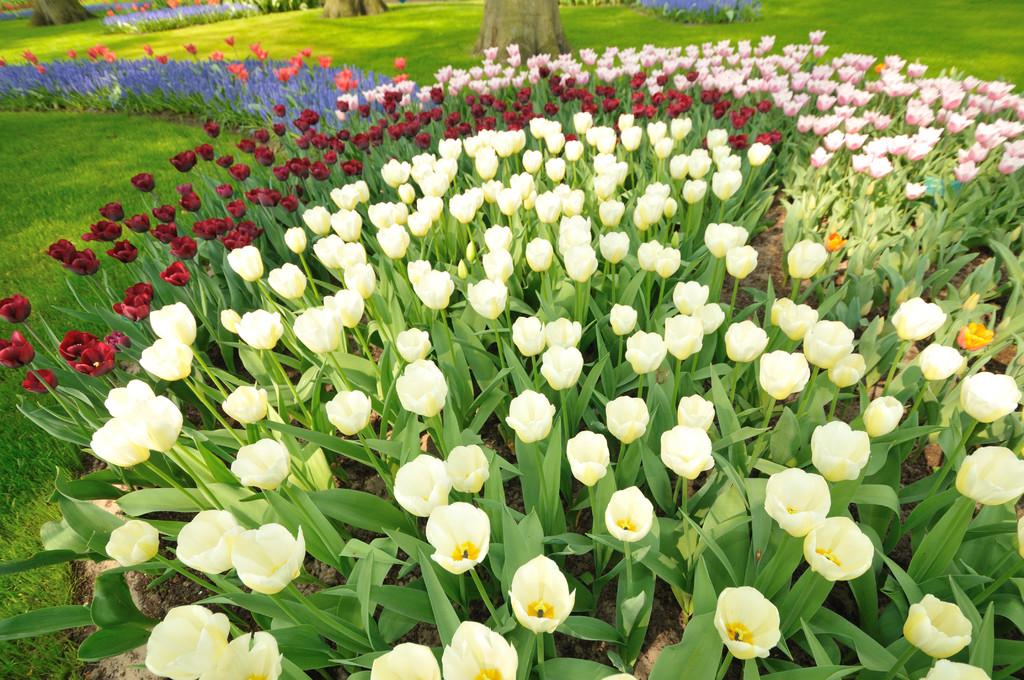What is the main subject in the center of the image? There are plants and flowers in the center of the image. What type of vegetation can be seen at the top of the image? There are trees visible at the top of the image. What type of ground cover is present in the background of the image? There is grass in the background of the image. What type of bone is visible in the image? There is no bone present in the image. What type of stone can be seen in the image? There is no stone present in the image. 